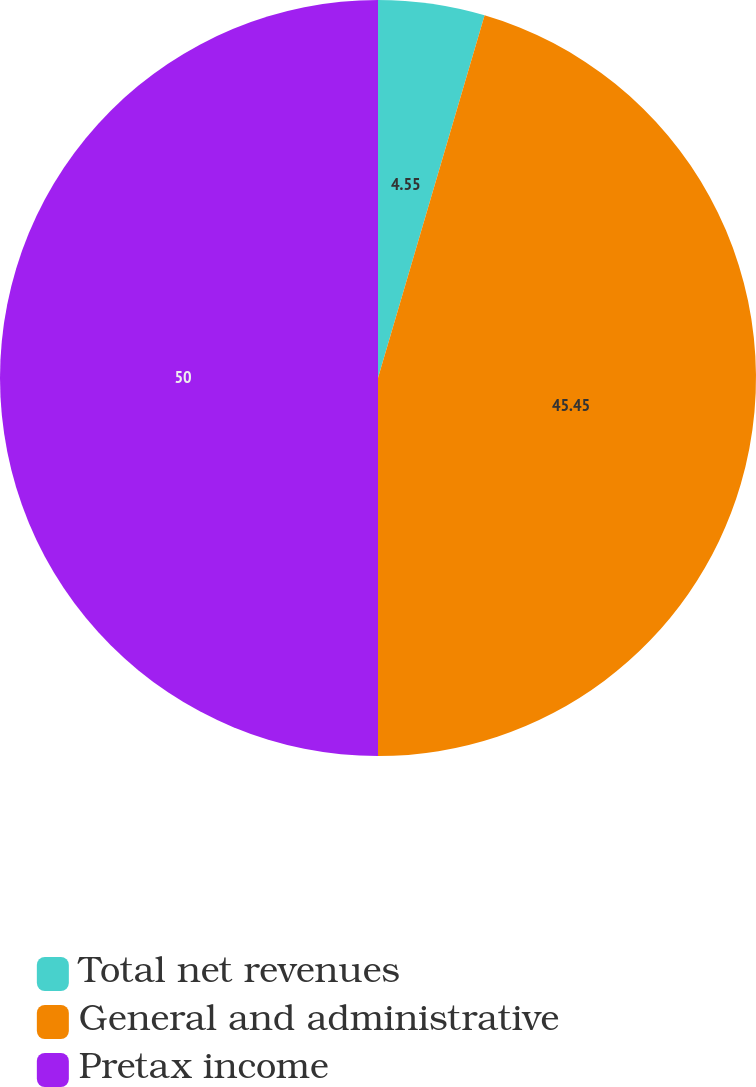<chart> <loc_0><loc_0><loc_500><loc_500><pie_chart><fcel>Total net revenues<fcel>General and administrative<fcel>Pretax income<nl><fcel>4.55%<fcel>45.45%<fcel>50.0%<nl></chart> 